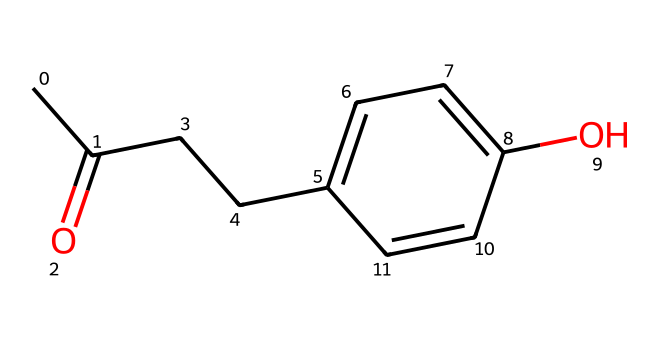What is the molecular formula of raspberry ketone? The given SMILES representation shows the molecular structure of raspberry ketone. By analyzing the structure, we can count the number of carbon, hydrogen, and oxygen atoms. There are 10 carbon atoms (C), 12 hydrogen atoms (H), and 1 oxygen atom (O) in the chemical. Therefore, the molecular formula is C10H12O.
Answer: C10H12O How many rings are present in the structure of raspberry ketone? Observing the SMILES representation, we can see that there are no closed loops or ring structures in the chemical formula. The structure consists of a straight chain and a phenolic group but no circular arrangement of atoms. Thus, the count of rings is zero.
Answer: zero What functional group is present in raspberry ketone? In the given SMILES, there is a carbonyl group (C=O) present in the structure. This carbonyl indicates the presence of a ketone. Furthermore, the -OH group (hydroxyl) shows that there is also a phenolic aspect to the compound. Therefore, the primary functional group identified here is the carbonyl, marking it as a ketone.
Answer: ketone How many carbon atoms are in the phenolic ring of raspberry ketone? The structure contains a phenolic ring represented in the SMILES. In a phenolic ring, there are six carbon atoms involved in the cyclic structure. Therefore, counting the carbon atoms present specifically in the phenolic part, we arrive at six.
Answer: six What type of bonds are predominant in raspberry ketone? When analyzing the SMILES structure, we recognize both single (sigma) and double (pi) bonds. The double bond appears in the carbonyl group (C=O), while the remaining bonds among carbon atoms and between carbon and hydrogen atoms are single bonds. Thus, the predominant bond type is the single bond.
Answer: single bond Is raspberry ketone a saturated or unsaturated compound? By examining the analysis of the structure, we see the presence of a double bond in the carbonyl group, indicating that the compound includes unsaturation. Thus, given this characteristic, raspberry ketone is classified as an unsaturated compound, as it contains at least one double bond.
Answer: unsaturated 